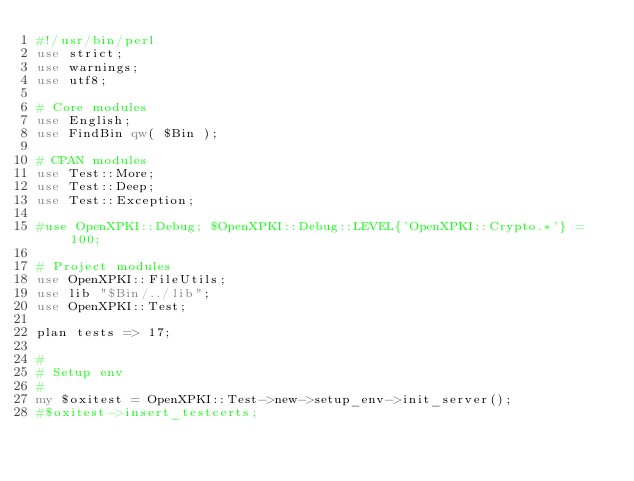Convert code to text. <code><loc_0><loc_0><loc_500><loc_500><_Perl_>#!/usr/bin/perl
use strict;
use warnings;
use utf8;

# Core modules
use English;
use FindBin qw( $Bin );

# CPAN modules
use Test::More;
use Test::Deep;
use Test::Exception;

#use OpenXPKI::Debug; $OpenXPKI::Debug::LEVEL{'OpenXPKI::Crypto.*'} = 100;

# Project modules
use OpenXPKI::FileUtils;
use lib "$Bin/../lib";
use OpenXPKI::Test;

plan tests => 17;

#
# Setup env
#
my $oxitest = OpenXPKI::Test->new->setup_env->init_server();
#$oxitest->insert_testcerts;
</code> 